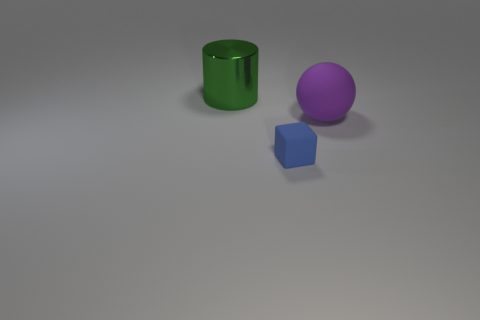Is the ball the same color as the big metallic cylinder?
Provide a short and direct response. No. Are there fewer big metallic cylinders than brown matte cylinders?
Ensure brevity in your answer.  No. Do the big object that is to the left of the purple rubber sphere and the big thing that is to the right of the metallic cylinder have the same material?
Your response must be concise. No. Is the number of small rubber objects to the right of the purple rubber ball less than the number of blue rubber blocks?
Your answer should be very brief. Yes. What number of things are left of the matte thing behind the rubber cube?
Make the answer very short. 2. There is a thing that is both to the left of the purple rubber sphere and right of the big metallic thing; how big is it?
Keep it short and to the point. Small. Are there any other things that are made of the same material as the large sphere?
Give a very brief answer. Yes. Does the big purple object have the same material as the object that is to the left of the cube?
Provide a succinct answer. No. Are there fewer tiny matte blocks that are on the right side of the purple rubber object than big metal things in front of the big metal object?
Ensure brevity in your answer.  No. There is a big object that is in front of the green cylinder; what is its material?
Keep it short and to the point. Rubber. 